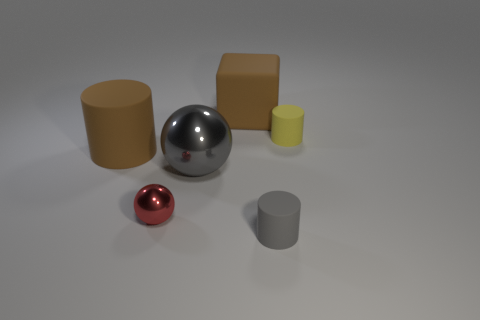Add 1 red matte cylinders. How many objects exist? 7 Subtract all purple cylinders. Subtract all yellow blocks. How many cylinders are left? 3 Subtract all cubes. How many objects are left? 5 Add 5 small red shiny spheres. How many small red shiny spheres exist? 6 Subtract 0 cyan cubes. How many objects are left? 6 Subtract all tiny gray matte cylinders. Subtract all big brown cylinders. How many objects are left? 4 Add 3 big metal objects. How many big metal objects are left? 4 